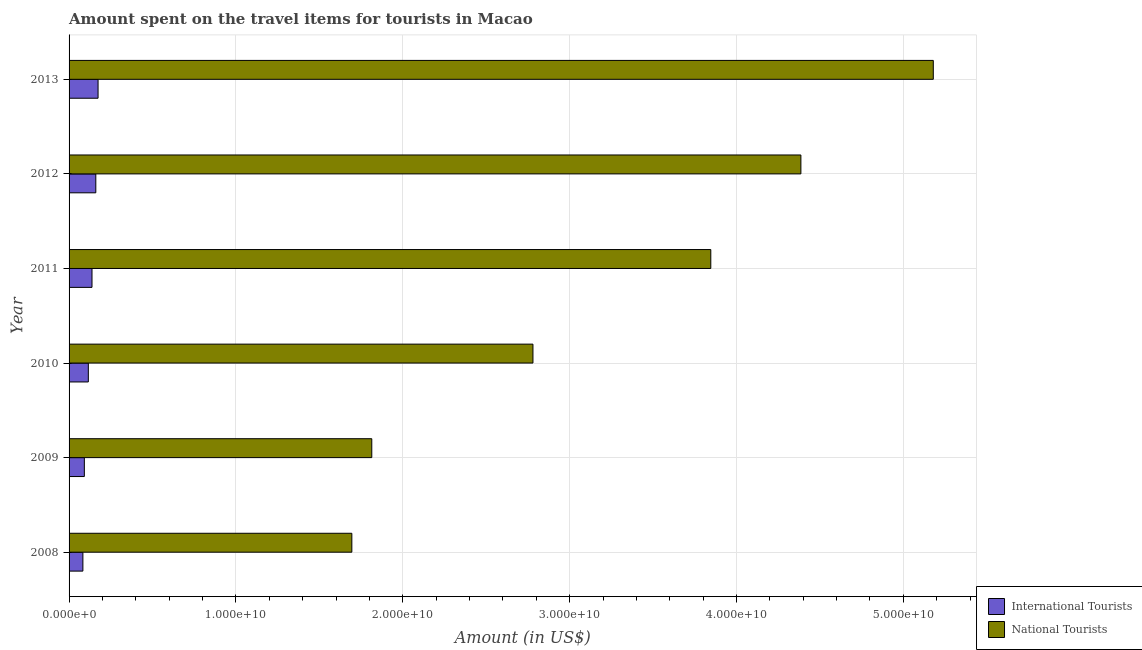How many different coloured bars are there?
Ensure brevity in your answer.  2. How many groups of bars are there?
Give a very brief answer. 6. Are the number of bars per tick equal to the number of legend labels?
Your answer should be compact. Yes. Are the number of bars on each tick of the Y-axis equal?
Your answer should be very brief. Yes. How many bars are there on the 4th tick from the top?
Keep it short and to the point. 2. How many bars are there on the 3rd tick from the bottom?
Keep it short and to the point. 2. In how many cases, is the number of bars for a given year not equal to the number of legend labels?
Make the answer very short. 0. What is the amount spent on travel items of national tourists in 2013?
Make the answer very short. 5.18e+1. Across all years, what is the maximum amount spent on travel items of international tourists?
Offer a very short reply. 1.74e+09. Across all years, what is the minimum amount spent on travel items of national tourists?
Ensure brevity in your answer.  1.69e+1. In which year was the amount spent on travel items of international tourists minimum?
Offer a very short reply. 2008. What is the total amount spent on travel items of international tourists in the graph?
Your response must be concise. 7.61e+09. What is the difference between the amount spent on travel items of international tourists in 2009 and that in 2010?
Your answer should be compact. -2.39e+08. What is the difference between the amount spent on travel items of national tourists in 2011 and the amount spent on travel items of international tourists in 2013?
Your answer should be very brief. 3.67e+1. What is the average amount spent on travel items of national tourists per year?
Your response must be concise. 3.28e+1. In the year 2009, what is the difference between the amount spent on travel items of national tourists and amount spent on travel items of international tourists?
Offer a very short reply. 1.72e+1. What is the ratio of the amount spent on travel items of national tourists in 2008 to that in 2011?
Offer a terse response. 0.44. Is the amount spent on travel items of national tourists in 2008 less than that in 2010?
Keep it short and to the point. Yes. Is the difference between the amount spent on travel items of international tourists in 2008 and 2010 greater than the difference between the amount spent on travel items of national tourists in 2008 and 2010?
Your response must be concise. Yes. What is the difference between the highest and the second highest amount spent on travel items of national tourists?
Your answer should be compact. 7.94e+09. What is the difference between the highest and the lowest amount spent on travel items of national tourists?
Make the answer very short. 3.48e+1. In how many years, is the amount spent on travel items of international tourists greater than the average amount spent on travel items of international tourists taken over all years?
Offer a terse response. 3. What does the 2nd bar from the top in 2013 represents?
Provide a succinct answer. International Tourists. What does the 2nd bar from the bottom in 2011 represents?
Provide a short and direct response. National Tourists. How many bars are there?
Provide a short and direct response. 12. Are all the bars in the graph horizontal?
Offer a terse response. Yes. What is the difference between two consecutive major ticks on the X-axis?
Offer a very short reply. 1.00e+1. Does the graph contain any zero values?
Your response must be concise. No. Does the graph contain grids?
Keep it short and to the point. Yes. Where does the legend appear in the graph?
Ensure brevity in your answer.  Bottom right. How many legend labels are there?
Provide a succinct answer. 2. What is the title of the graph?
Ensure brevity in your answer.  Amount spent on the travel items for tourists in Macao. Does "Female population" appear as one of the legend labels in the graph?
Your answer should be compact. No. What is the Amount (in US$) in International Tourists in 2008?
Provide a short and direct response. 8.28e+08. What is the Amount (in US$) in National Tourists in 2008?
Make the answer very short. 1.69e+1. What is the Amount (in US$) of International Tourists in 2009?
Your answer should be very brief. 9.15e+08. What is the Amount (in US$) in National Tourists in 2009?
Your answer should be compact. 1.81e+1. What is the Amount (in US$) in International Tourists in 2010?
Offer a very short reply. 1.15e+09. What is the Amount (in US$) in National Tourists in 2010?
Offer a terse response. 2.78e+1. What is the Amount (in US$) in International Tourists in 2011?
Your answer should be compact. 1.37e+09. What is the Amount (in US$) of National Tourists in 2011?
Provide a succinct answer. 3.85e+1. What is the Amount (in US$) of International Tourists in 2012?
Provide a short and direct response. 1.60e+09. What is the Amount (in US$) in National Tourists in 2012?
Provide a succinct answer. 4.39e+1. What is the Amount (in US$) in International Tourists in 2013?
Keep it short and to the point. 1.74e+09. What is the Amount (in US$) in National Tourists in 2013?
Provide a short and direct response. 5.18e+1. Across all years, what is the maximum Amount (in US$) of International Tourists?
Your answer should be very brief. 1.74e+09. Across all years, what is the maximum Amount (in US$) of National Tourists?
Your response must be concise. 5.18e+1. Across all years, what is the minimum Amount (in US$) of International Tourists?
Your answer should be compact. 8.28e+08. Across all years, what is the minimum Amount (in US$) in National Tourists?
Keep it short and to the point. 1.69e+1. What is the total Amount (in US$) in International Tourists in the graph?
Ensure brevity in your answer.  7.61e+09. What is the total Amount (in US$) of National Tourists in the graph?
Your response must be concise. 1.97e+11. What is the difference between the Amount (in US$) in International Tourists in 2008 and that in 2009?
Offer a terse response. -8.70e+07. What is the difference between the Amount (in US$) of National Tourists in 2008 and that in 2009?
Ensure brevity in your answer.  -1.19e+09. What is the difference between the Amount (in US$) in International Tourists in 2008 and that in 2010?
Your answer should be very brief. -3.26e+08. What is the difference between the Amount (in US$) of National Tourists in 2008 and that in 2010?
Your response must be concise. -1.09e+1. What is the difference between the Amount (in US$) in International Tourists in 2008 and that in 2011?
Offer a terse response. -5.46e+08. What is the difference between the Amount (in US$) in National Tourists in 2008 and that in 2011?
Provide a succinct answer. -2.15e+1. What is the difference between the Amount (in US$) in International Tourists in 2008 and that in 2012?
Your answer should be compact. -7.75e+08. What is the difference between the Amount (in US$) of National Tourists in 2008 and that in 2012?
Keep it short and to the point. -2.69e+1. What is the difference between the Amount (in US$) of International Tourists in 2008 and that in 2013?
Offer a terse response. -9.10e+08. What is the difference between the Amount (in US$) of National Tourists in 2008 and that in 2013?
Offer a terse response. -3.48e+1. What is the difference between the Amount (in US$) in International Tourists in 2009 and that in 2010?
Keep it short and to the point. -2.39e+08. What is the difference between the Amount (in US$) of National Tourists in 2009 and that in 2010?
Your response must be concise. -9.66e+09. What is the difference between the Amount (in US$) of International Tourists in 2009 and that in 2011?
Your answer should be compact. -4.59e+08. What is the difference between the Amount (in US$) of National Tourists in 2009 and that in 2011?
Make the answer very short. -2.03e+1. What is the difference between the Amount (in US$) in International Tourists in 2009 and that in 2012?
Make the answer very short. -6.88e+08. What is the difference between the Amount (in US$) in National Tourists in 2009 and that in 2012?
Make the answer very short. -2.57e+1. What is the difference between the Amount (in US$) of International Tourists in 2009 and that in 2013?
Your response must be concise. -8.23e+08. What is the difference between the Amount (in US$) of National Tourists in 2009 and that in 2013?
Keep it short and to the point. -3.37e+1. What is the difference between the Amount (in US$) of International Tourists in 2010 and that in 2011?
Your answer should be compact. -2.20e+08. What is the difference between the Amount (in US$) in National Tourists in 2010 and that in 2011?
Your answer should be compact. -1.07e+1. What is the difference between the Amount (in US$) in International Tourists in 2010 and that in 2012?
Make the answer very short. -4.49e+08. What is the difference between the Amount (in US$) of National Tourists in 2010 and that in 2012?
Give a very brief answer. -1.61e+1. What is the difference between the Amount (in US$) in International Tourists in 2010 and that in 2013?
Your answer should be compact. -5.84e+08. What is the difference between the Amount (in US$) of National Tourists in 2010 and that in 2013?
Provide a short and direct response. -2.40e+1. What is the difference between the Amount (in US$) of International Tourists in 2011 and that in 2012?
Ensure brevity in your answer.  -2.29e+08. What is the difference between the Amount (in US$) in National Tourists in 2011 and that in 2012?
Provide a short and direct response. -5.40e+09. What is the difference between the Amount (in US$) in International Tourists in 2011 and that in 2013?
Your answer should be compact. -3.64e+08. What is the difference between the Amount (in US$) in National Tourists in 2011 and that in 2013?
Make the answer very short. -1.33e+1. What is the difference between the Amount (in US$) of International Tourists in 2012 and that in 2013?
Ensure brevity in your answer.  -1.35e+08. What is the difference between the Amount (in US$) of National Tourists in 2012 and that in 2013?
Make the answer very short. -7.94e+09. What is the difference between the Amount (in US$) of International Tourists in 2008 and the Amount (in US$) of National Tourists in 2009?
Your answer should be very brief. -1.73e+1. What is the difference between the Amount (in US$) in International Tourists in 2008 and the Amount (in US$) in National Tourists in 2010?
Your response must be concise. -2.70e+1. What is the difference between the Amount (in US$) of International Tourists in 2008 and the Amount (in US$) of National Tourists in 2011?
Provide a short and direct response. -3.76e+1. What is the difference between the Amount (in US$) in International Tourists in 2008 and the Amount (in US$) in National Tourists in 2012?
Ensure brevity in your answer.  -4.30e+1. What is the difference between the Amount (in US$) in International Tourists in 2008 and the Amount (in US$) in National Tourists in 2013?
Offer a terse response. -5.10e+1. What is the difference between the Amount (in US$) in International Tourists in 2009 and the Amount (in US$) in National Tourists in 2010?
Provide a short and direct response. -2.69e+1. What is the difference between the Amount (in US$) of International Tourists in 2009 and the Amount (in US$) of National Tourists in 2011?
Keep it short and to the point. -3.75e+1. What is the difference between the Amount (in US$) in International Tourists in 2009 and the Amount (in US$) in National Tourists in 2012?
Your answer should be compact. -4.29e+1. What is the difference between the Amount (in US$) in International Tourists in 2009 and the Amount (in US$) in National Tourists in 2013?
Keep it short and to the point. -5.09e+1. What is the difference between the Amount (in US$) in International Tourists in 2010 and the Amount (in US$) in National Tourists in 2011?
Your answer should be very brief. -3.73e+1. What is the difference between the Amount (in US$) in International Tourists in 2010 and the Amount (in US$) in National Tourists in 2012?
Your answer should be very brief. -4.27e+1. What is the difference between the Amount (in US$) in International Tourists in 2010 and the Amount (in US$) in National Tourists in 2013?
Your answer should be compact. -5.06e+1. What is the difference between the Amount (in US$) of International Tourists in 2011 and the Amount (in US$) of National Tourists in 2012?
Your response must be concise. -4.25e+1. What is the difference between the Amount (in US$) of International Tourists in 2011 and the Amount (in US$) of National Tourists in 2013?
Your response must be concise. -5.04e+1. What is the difference between the Amount (in US$) of International Tourists in 2012 and the Amount (in US$) of National Tourists in 2013?
Provide a short and direct response. -5.02e+1. What is the average Amount (in US$) of International Tourists per year?
Offer a terse response. 1.27e+09. What is the average Amount (in US$) in National Tourists per year?
Make the answer very short. 3.28e+1. In the year 2008, what is the difference between the Amount (in US$) in International Tourists and Amount (in US$) in National Tourists?
Your answer should be compact. -1.61e+1. In the year 2009, what is the difference between the Amount (in US$) in International Tourists and Amount (in US$) in National Tourists?
Provide a short and direct response. -1.72e+1. In the year 2010, what is the difference between the Amount (in US$) of International Tourists and Amount (in US$) of National Tourists?
Make the answer very short. -2.66e+1. In the year 2011, what is the difference between the Amount (in US$) in International Tourists and Amount (in US$) in National Tourists?
Provide a succinct answer. -3.71e+1. In the year 2012, what is the difference between the Amount (in US$) in International Tourists and Amount (in US$) in National Tourists?
Give a very brief answer. -4.23e+1. In the year 2013, what is the difference between the Amount (in US$) of International Tourists and Amount (in US$) of National Tourists?
Provide a succinct answer. -5.01e+1. What is the ratio of the Amount (in US$) in International Tourists in 2008 to that in 2009?
Keep it short and to the point. 0.9. What is the ratio of the Amount (in US$) in National Tourists in 2008 to that in 2009?
Ensure brevity in your answer.  0.93. What is the ratio of the Amount (in US$) of International Tourists in 2008 to that in 2010?
Keep it short and to the point. 0.72. What is the ratio of the Amount (in US$) in National Tourists in 2008 to that in 2010?
Ensure brevity in your answer.  0.61. What is the ratio of the Amount (in US$) in International Tourists in 2008 to that in 2011?
Give a very brief answer. 0.6. What is the ratio of the Amount (in US$) of National Tourists in 2008 to that in 2011?
Give a very brief answer. 0.44. What is the ratio of the Amount (in US$) in International Tourists in 2008 to that in 2012?
Your response must be concise. 0.52. What is the ratio of the Amount (in US$) in National Tourists in 2008 to that in 2012?
Your answer should be compact. 0.39. What is the ratio of the Amount (in US$) in International Tourists in 2008 to that in 2013?
Keep it short and to the point. 0.48. What is the ratio of the Amount (in US$) in National Tourists in 2008 to that in 2013?
Offer a very short reply. 0.33. What is the ratio of the Amount (in US$) in International Tourists in 2009 to that in 2010?
Give a very brief answer. 0.79. What is the ratio of the Amount (in US$) in National Tourists in 2009 to that in 2010?
Your response must be concise. 0.65. What is the ratio of the Amount (in US$) of International Tourists in 2009 to that in 2011?
Provide a short and direct response. 0.67. What is the ratio of the Amount (in US$) in National Tourists in 2009 to that in 2011?
Offer a very short reply. 0.47. What is the ratio of the Amount (in US$) of International Tourists in 2009 to that in 2012?
Your answer should be compact. 0.57. What is the ratio of the Amount (in US$) in National Tourists in 2009 to that in 2012?
Keep it short and to the point. 0.41. What is the ratio of the Amount (in US$) of International Tourists in 2009 to that in 2013?
Give a very brief answer. 0.53. What is the ratio of the Amount (in US$) in National Tourists in 2009 to that in 2013?
Provide a succinct answer. 0.35. What is the ratio of the Amount (in US$) in International Tourists in 2010 to that in 2011?
Ensure brevity in your answer.  0.84. What is the ratio of the Amount (in US$) of National Tourists in 2010 to that in 2011?
Offer a terse response. 0.72. What is the ratio of the Amount (in US$) of International Tourists in 2010 to that in 2012?
Your response must be concise. 0.72. What is the ratio of the Amount (in US$) of National Tourists in 2010 to that in 2012?
Your response must be concise. 0.63. What is the ratio of the Amount (in US$) in International Tourists in 2010 to that in 2013?
Offer a very short reply. 0.66. What is the ratio of the Amount (in US$) in National Tourists in 2010 to that in 2013?
Keep it short and to the point. 0.54. What is the ratio of the Amount (in US$) in International Tourists in 2011 to that in 2012?
Offer a very short reply. 0.86. What is the ratio of the Amount (in US$) of National Tourists in 2011 to that in 2012?
Your response must be concise. 0.88. What is the ratio of the Amount (in US$) in International Tourists in 2011 to that in 2013?
Your response must be concise. 0.79. What is the ratio of the Amount (in US$) in National Tourists in 2011 to that in 2013?
Your response must be concise. 0.74. What is the ratio of the Amount (in US$) in International Tourists in 2012 to that in 2013?
Provide a short and direct response. 0.92. What is the ratio of the Amount (in US$) in National Tourists in 2012 to that in 2013?
Provide a short and direct response. 0.85. What is the difference between the highest and the second highest Amount (in US$) in International Tourists?
Provide a succinct answer. 1.35e+08. What is the difference between the highest and the second highest Amount (in US$) in National Tourists?
Your answer should be compact. 7.94e+09. What is the difference between the highest and the lowest Amount (in US$) of International Tourists?
Your answer should be compact. 9.10e+08. What is the difference between the highest and the lowest Amount (in US$) of National Tourists?
Give a very brief answer. 3.48e+1. 